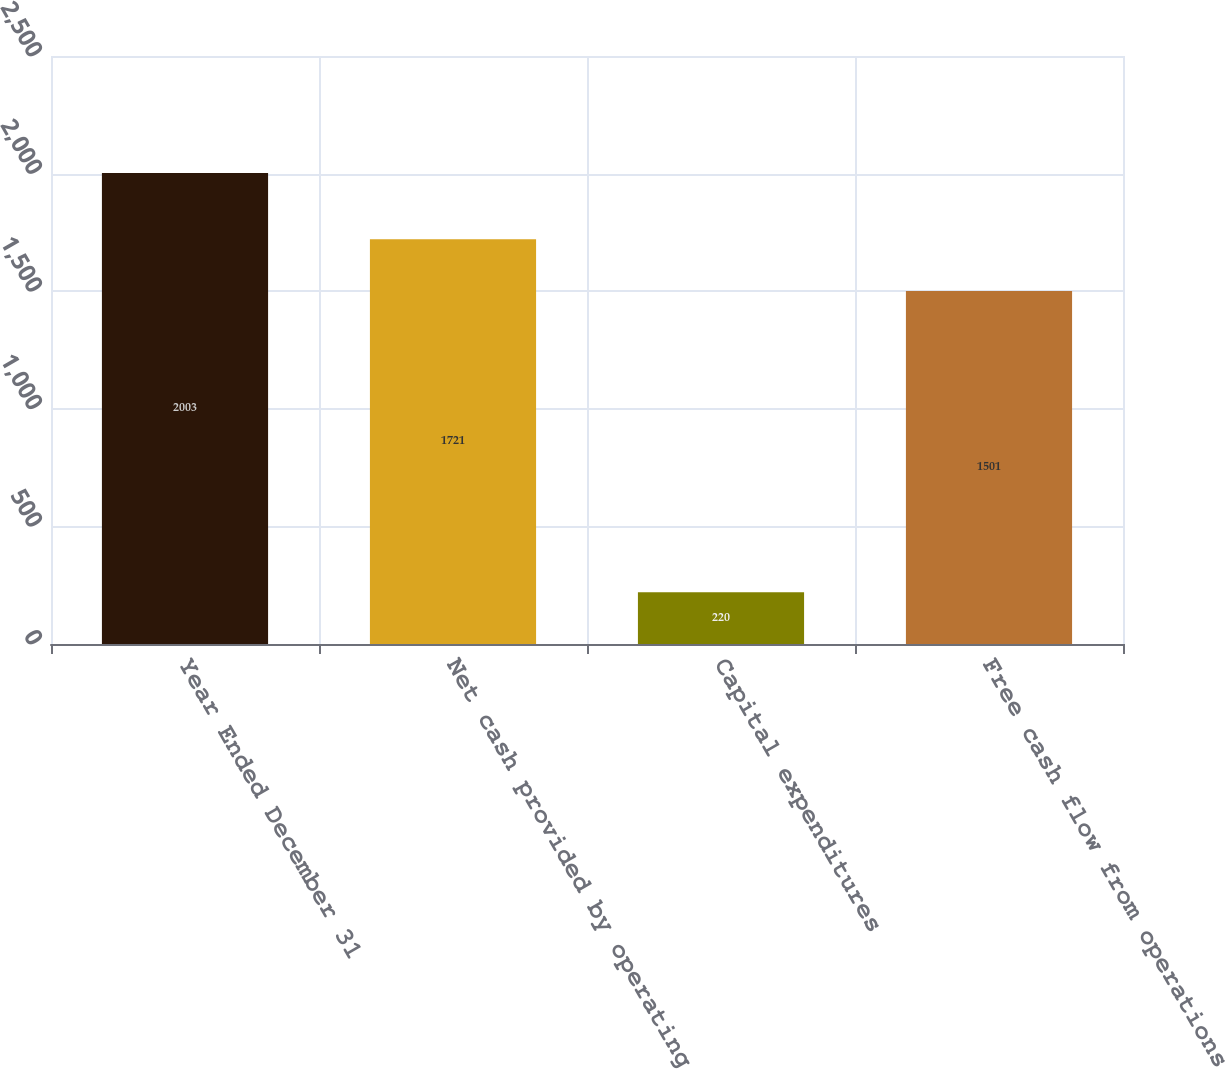<chart> <loc_0><loc_0><loc_500><loc_500><bar_chart><fcel>Year Ended December 31<fcel>Net cash provided by operating<fcel>Capital expenditures<fcel>Free cash flow from operations<nl><fcel>2003<fcel>1721<fcel>220<fcel>1501<nl></chart> 